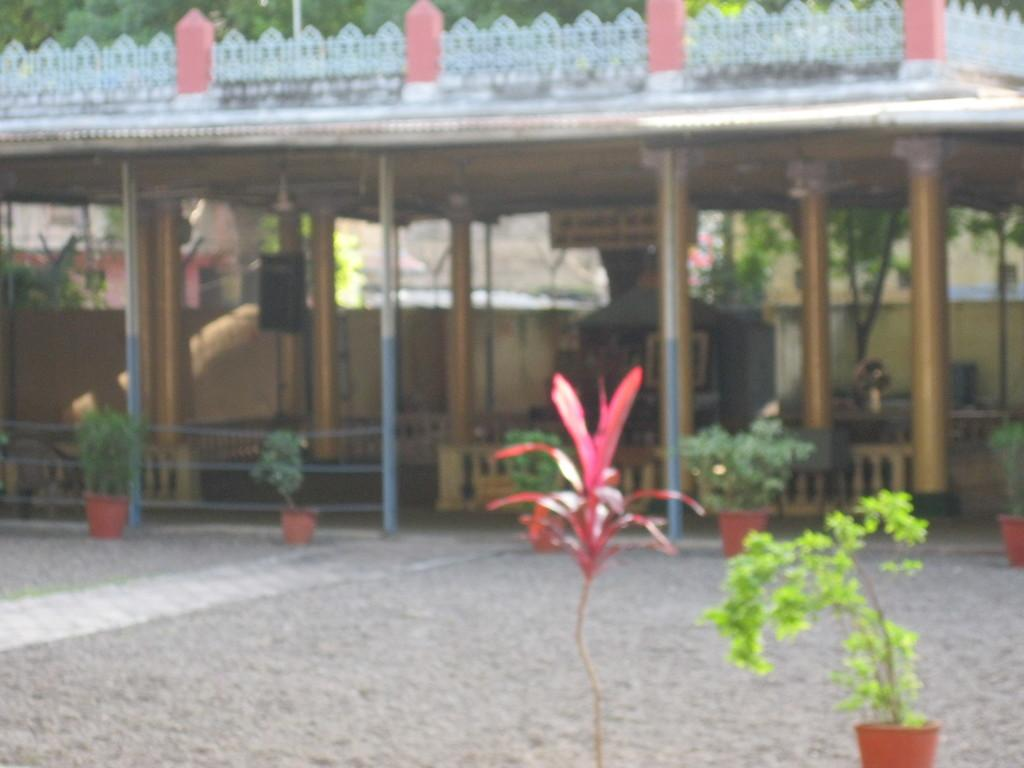What type of structures can be seen in the image? There are pillars and a shed visible in the image. What else can be found in the image besides the structures? There are plants and a fence visible in the image. Are there any enclosed spaces in the image? Yes, there are walls visible in the image. What type of glass is being taught in the image? There is no glass or teaching activity present in the image. 